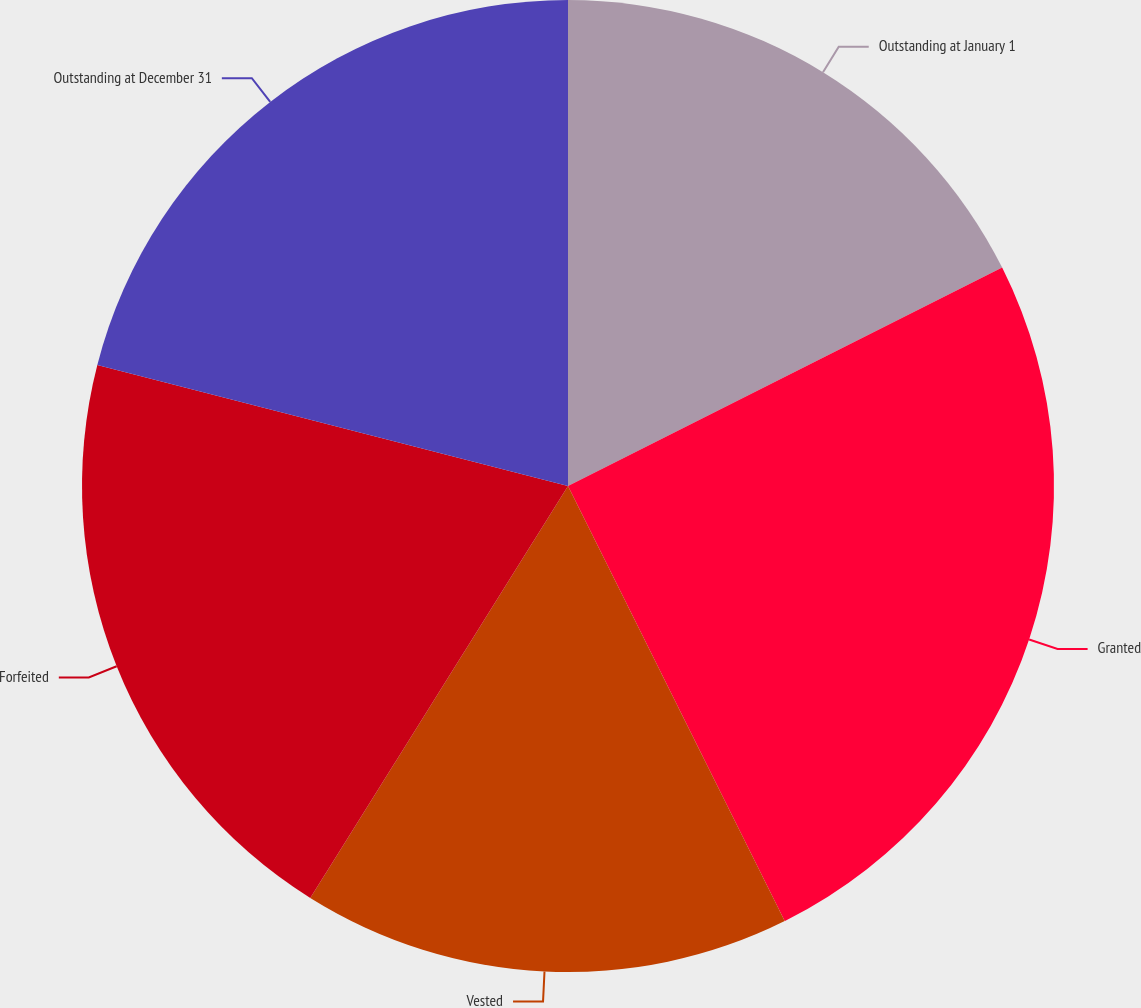Convert chart. <chart><loc_0><loc_0><loc_500><loc_500><pie_chart><fcel>Outstanding at January 1<fcel>Granted<fcel>Vested<fcel>Forfeited<fcel>Outstanding at December 31<nl><fcel>17.58%<fcel>25.06%<fcel>16.25%<fcel>20.11%<fcel>20.99%<nl></chart> 